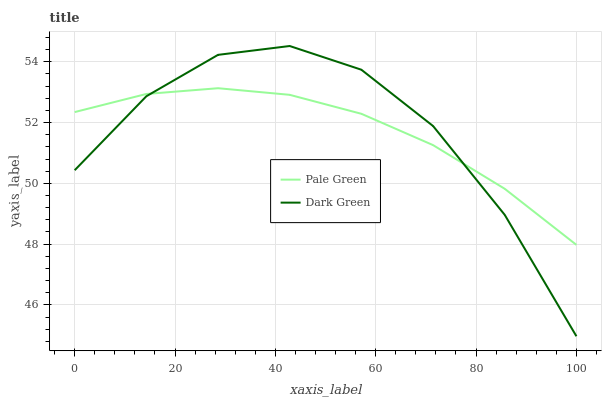Does Pale Green have the minimum area under the curve?
Answer yes or no. Yes. Does Dark Green have the maximum area under the curve?
Answer yes or no. Yes. Does Dark Green have the minimum area under the curve?
Answer yes or no. No. Is Pale Green the smoothest?
Answer yes or no. Yes. Is Dark Green the roughest?
Answer yes or no. Yes. Is Dark Green the smoothest?
Answer yes or no. No. Does Dark Green have the highest value?
Answer yes or no. Yes. 